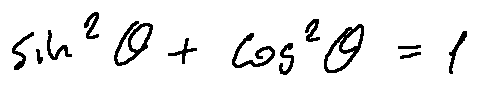<formula> <loc_0><loc_0><loc_500><loc_500>\sin ^ { 2 } \theta + \cos ^ { 2 } \theta = 1</formula> 